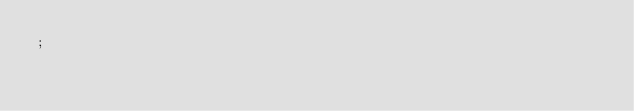Convert code to text. <code><loc_0><loc_0><loc_500><loc_500><_SQL_>;
</code> 